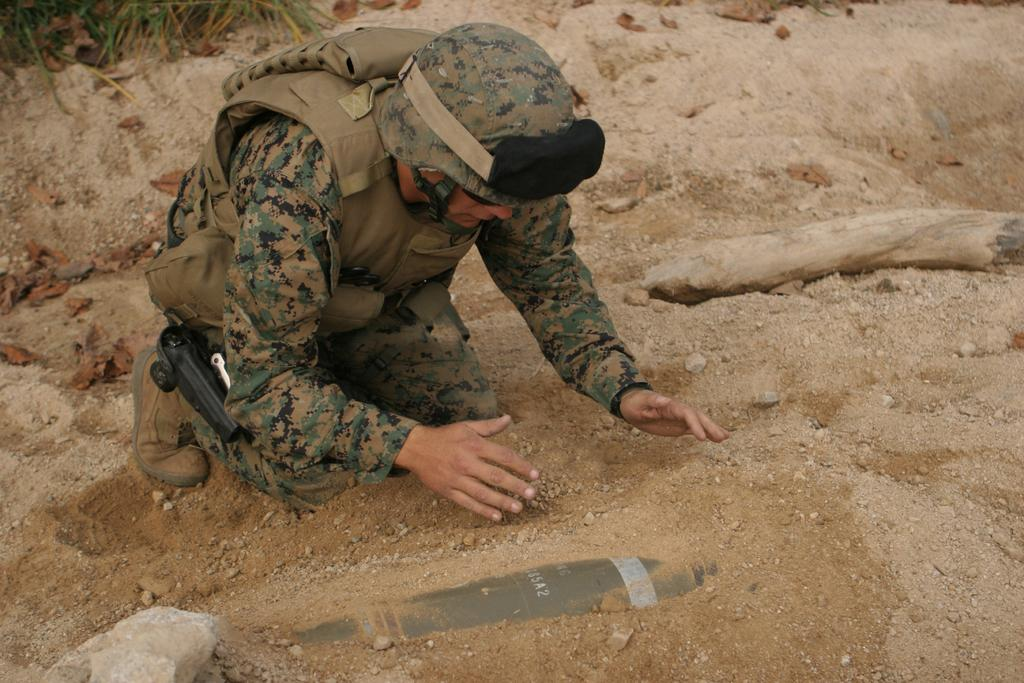What is the person in the image wearing? The person is wearing an army uniform, a jacket, a helmet, and shoes. What is the person doing in the image? The person is sitting on the ground. What can be seen in the background of the image? There are stones and plants in the image. How many bones can be seen sticking out of the person's legs in the image? There are no bones visible in the image, and the person's legs are not depicted as injured or broken. 